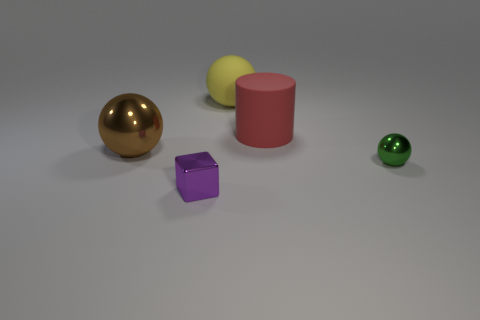Subtract all metal balls. How many balls are left? 1 Subtract 1 cylinders. How many cylinders are left? 0 Subtract all cylinders. How many objects are left? 4 Subtract all purple cylinders. How many cyan blocks are left? 0 Add 2 large metallic balls. How many objects exist? 7 Subtract 0 blue blocks. How many objects are left? 5 Subtract all blue cylinders. Subtract all green cubes. How many cylinders are left? 1 Subtract all large cylinders. Subtract all green balls. How many objects are left? 3 Add 1 green shiny balls. How many green shiny balls are left? 2 Add 3 purple shiny objects. How many purple shiny objects exist? 4 